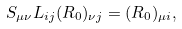<formula> <loc_0><loc_0><loc_500><loc_500>S _ { \mu \nu } L _ { i j } ( R _ { 0 } ) _ { \nu j } = ( R _ { 0 } ) _ { \mu i } ,</formula> 